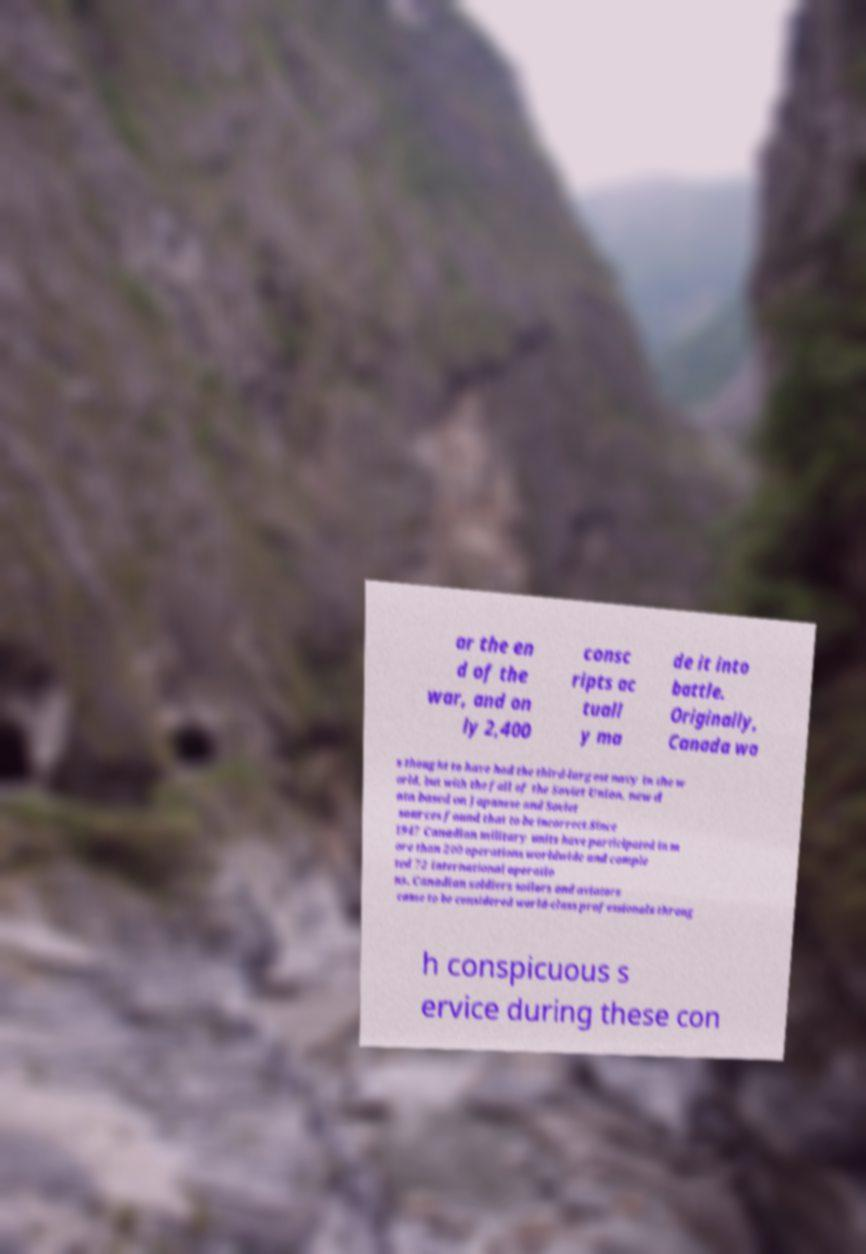What messages or text are displayed in this image? I need them in a readable, typed format. ar the en d of the war, and on ly 2,400 consc ripts ac tuall y ma de it into battle. Originally, Canada wa s thought to have had the third-largest navy in the w orld, but with the fall of the Soviet Union, new d ata based on Japanese and Soviet sources found that to be incorrect.Since 1947 Canadian military units have participated in m ore than 200 operations worldwide and comple ted 72 international operatio ns. Canadian soldiers sailors and aviators came to be considered world-class professionals throug h conspicuous s ervice during these con 